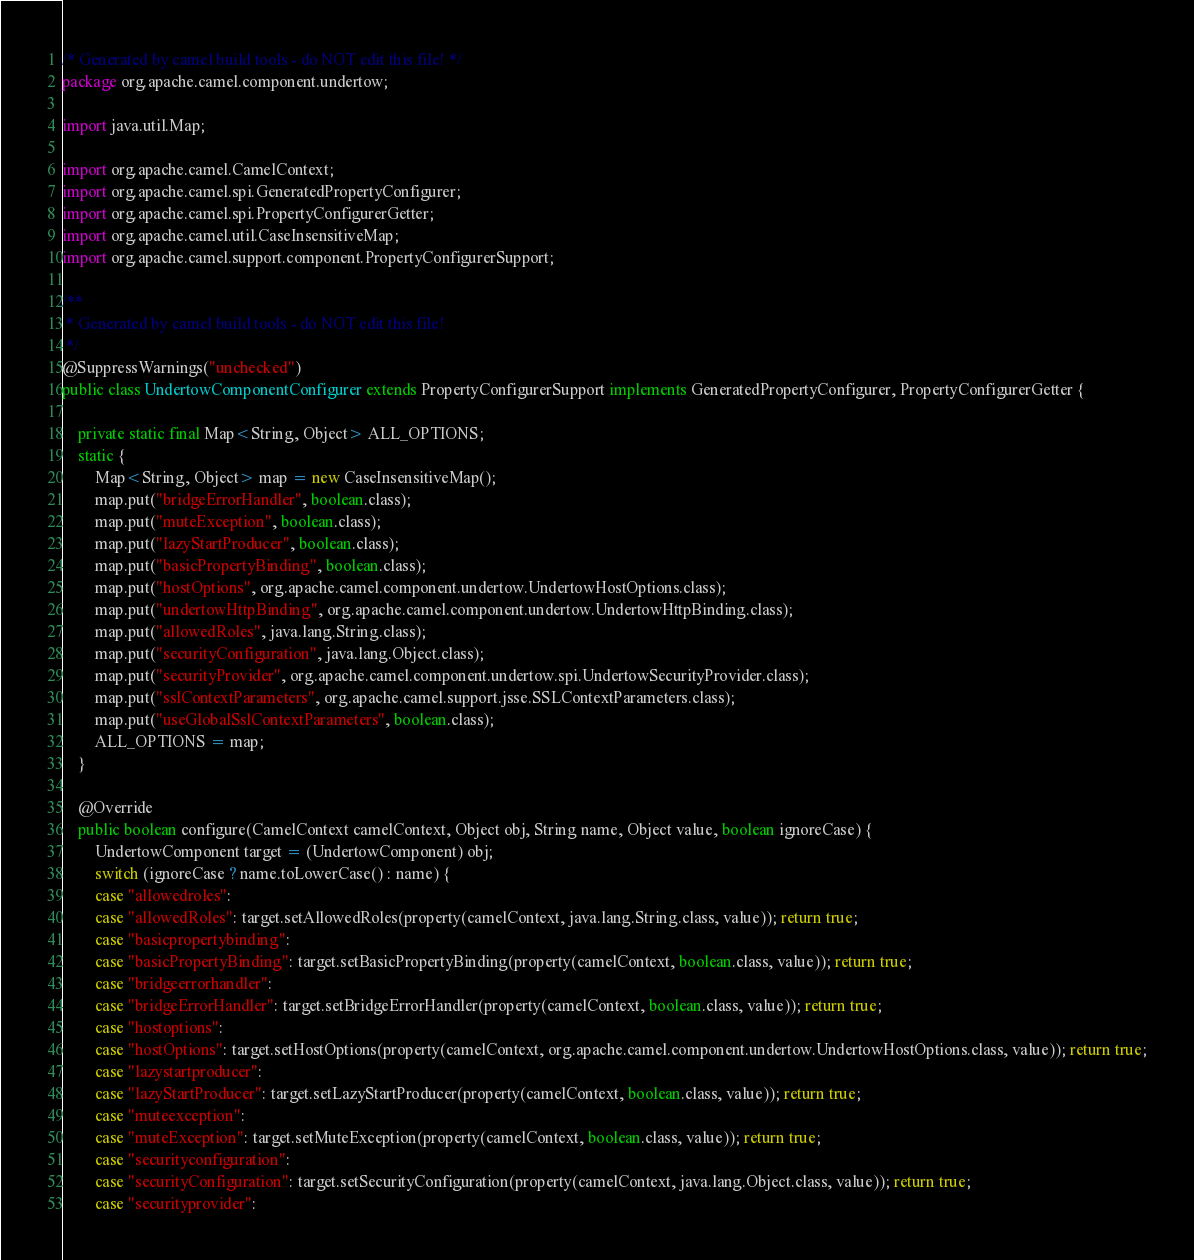<code> <loc_0><loc_0><loc_500><loc_500><_Java_>/* Generated by camel build tools - do NOT edit this file! */
package org.apache.camel.component.undertow;

import java.util.Map;

import org.apache.camel.CamelContext;
import org.apache.camel.spi.GeneratedPropertyConfigurer;
import org.apache.camel.spi.PropertyConfigurerGetter;
import org.apache.camel.util.CaseInsensitiveMap;
import org.apache.camel.support.component.PropertyConfigurerSupport;

/**
 * Generated by camel build tools - do NOT edit this file!
 */
@SuppressWarnings("unchecked")
public class UndertowComponentConfigurer extends PropertyConfigurerSupport implements GeneratedPropertyConfigurer, PropertyConfigurerGetter {

    private static final Map<String, Object> ALL_OPTIONS;
    static {
        Map<String, Object> map = new CaseInsensitiveMap();
        map.put("bridgeErrorHandler", boolean.class);
        map.put("muteException", boolean.class);
        map.put("lazyStartProducer", boolean.class);
        map.put("basicPropertyBinding", boolean.class);
        map.put("hostOptions", org.apache.camel.component.undertow.UndertowHostOptions.class);
        map.put("undertowHttpBinding", org.apache.camel.component.undertow.UndertowHttpBinding.class);
        map.put("allowedRoles", java.lang.String.class);
        map.put("securityConfiguration", java.lang.Object.class);
        map.put("securityProvider", org.apache.camel.component.undertow.spi.UndertowSecurityProvider.class);
        map.put("sslContextParameters", org.apache.camel.support.jsse.SSLContextParameters.class);
        map.put("useGlobalSslContextParameters", boolean.class);
        ALL_OPTIONS = map;
    }

    @Override
    public boolean configure(CamelContext camelContext, Object obj, String name, Object value, boolean ignoreCase) {
        UndertowComponent target = (UndertowComponent) obj;
        switch (ignoreCase ? name.toLowerCase() : name) {
        case "allowedroles":
        case "allowedRoles": target.setAllowedRoles(property(camelContext, java.lang.String.class, value)); return true;
        case "basicpropertybinding":
        case "basicPropertyBinding": target.setBasicPropertyBinding(property(camelContext, boolean.class, value)); return true;
        case "bridgeerrorhandler":
        case "bridgeErrorHandler": target.setBridgeErrorHandler(property(camelContext, boolean.class, value)); return true;
        case "hostoptions":
        case "hostOptions": target.setHostOptions(property(camelContext, org.apache.camel.component.undertow.UndertowHostOptions.class, value)); return true;
        case "lazystartproducer":
        case "lazyStartProducer": target.setLazyStartProducer(property(camelContext, boolean.class, value)); return true;
        case "muteexception":
        case "muteException": target.setMuteException(property(camelContext, boolean.class, value)); return true;
        case "securityconfiguration":
        case "securityConfiguration": target.setSecurityConfiguration(property(camelContext, java.lang.Object.class, value)); return true;
        case "securityprovider":</code> 